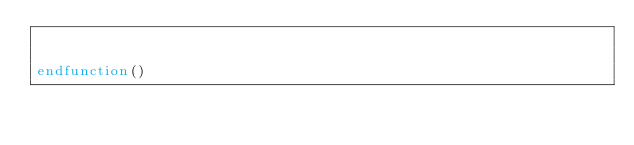Convert code to text. <code><loc_0><loc_0><loc_500><loc_500><_CMake_>

endfunction()</code> 